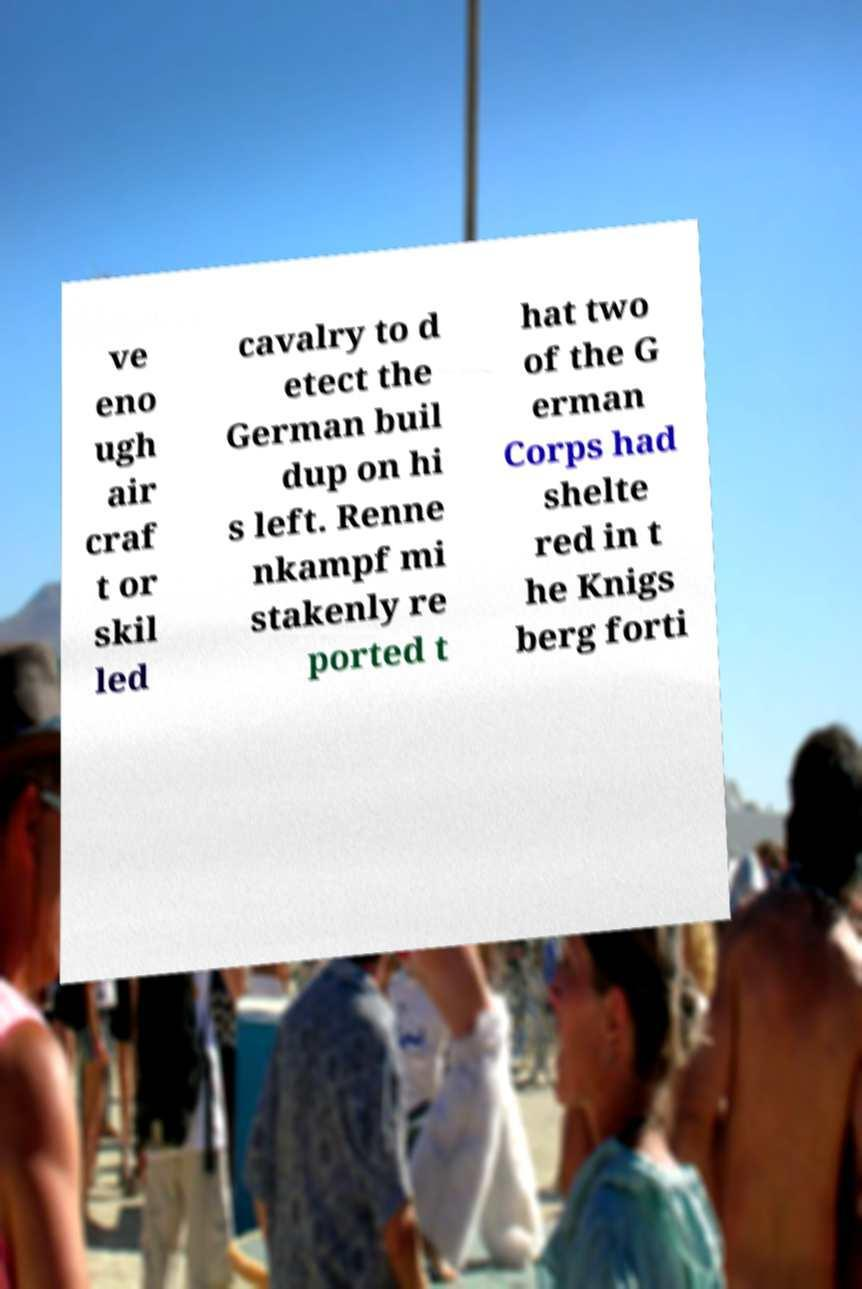Can you read and provide the text displayed in the image?This photo seems to have some interesting text. Can you extract and type it out for me? ve eno ugh air craf t or skil led cavalry to d etect the German buil dup on hi s left. Renne nkampf mi stakenly re ported t hat two of the G erman Corps had shelte red in t he Knigs berg forti 